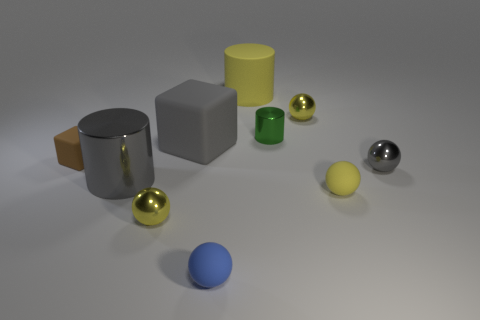Is there a ball on the right side of the small yellow metallic sphere that is in front of the metallic ball that is behind the green object?
Provide a short and direct response. Yes. Is the size of the brown rubber object the same as the gray metallic cylinder?
Give a very brief answer. No. The tiny matte thing left of the tiny blue rubber thing right of the cylinder left of the tiny blue object is what color?
Provide a succinct answer. Brown. How many rubber spheres are the same color as the small block?
Your answer should be compact. 0. How many small things are either purple metallic things or green metallic things?
Make the answer very short. 1. Is there another large thing of the same shape as the brown matte thing?
Your answer should be compact. Yes. Is the shape of the large gray metallic thing the same as the tiny yellow rubber thing?
Your answer should be very brief. No. The small metallic sphere that is right of the yellow metallic object that is behind the small brown cube is what color?
Ensure brevity in your answer.  Gray. The rubber object that is the same size as the yellow cylinder is what color?
Ensure brevity in your answer.  Gray. What number of metal objects are either gray objects or big gray things?
Your answer should be compact. 2. 